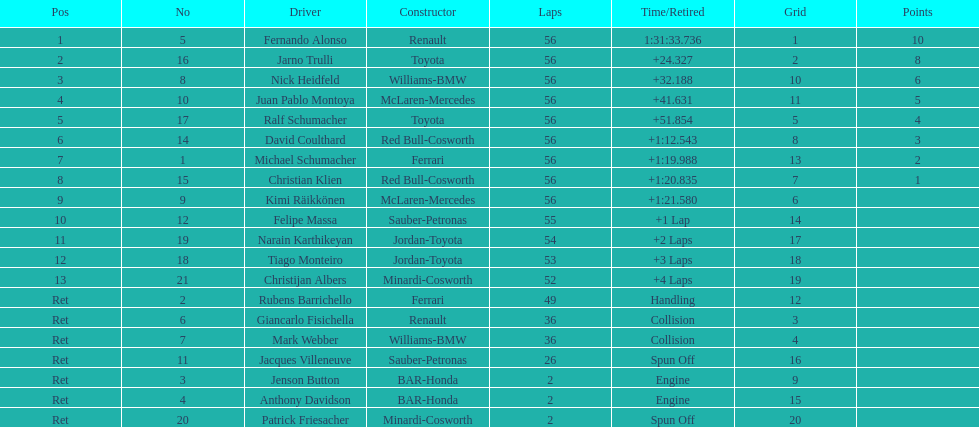In what amount of time did heidfeld complete? 1:31:65.924. Can you give me this table as a dict? {'header': ['Pos', 'No', 'Driver', 'Constructor', 'Laps', 'Time/Retired', 'Grid', 'Points'], 'rows': [['1', '5', 'Fernando Alonso', 'Renault', '56', '1:31:33.736', '1', '10'], ['2', '16', 'Jarno Trulli', 'Toyota', '56', '+24.327', '2', '8'], ['3', '8', 'Nick Heidfeld', 'Williams-BMW', '56', '+32.188', '10', '6'], ['4', '10', 'Juan Pablo Montoya', 'McLaren-Mercedes', '56', '+41.631', '11', '5'], ['5', '17', 'Ralf Schumacher', 'Toyota', '56', '+51.854', '5', '4'], ['6', '14', 'David Coulthard', 'Red Bull-Cosworth', '56', '+1:12.543', '8', '3'], ['7', '1', 'Michael Schumacher', 'Ferrari', '56', '+1:19.988', '13', '2'], ['8', '15', 'Christian Klien', 'Red Bull-Cosworth', '56', '+1:20.835', '7', '1'], ['9', '9', 'Kimi Räikkönen', 'McLaren-Mercedes', '56', '+1:21.580', '6', ''], ['10', '12', 'Felipe Massa', 'Sauber-Petronas', '55', '+1 Lap', '14', ''], ['11', '19', 'Narain Karthikeyan', 'Jordan-Toyota', '54', '+2 Laps', '17', ''], ['12', '18', 'Tiago Monteiro', 'Jordan-Toyota', '53', '+3 Laps', '18', ''], ['13', '21', 'Christijan Albers', 'Minardi-Cosworth', '52', '+4 Laps', '19', ''], ['Ret', '2', 'Rubens Barrichello', 'Ferrari', '49', 'Handling', '12', ''], ['Ret', '6', 'Giancarlo Fisichella', 'Renault', '36', 'Collision', '3', ''], ['Ret', '7', 'Mark Webber', 'Williams-BMW', '36', 'Collision', '4', ''], ['Ret', '11', 'Jacques Villeneuve', 'Sauber-Petronas', '26', 'Spun Off', '16', ''], ['Ret', '3', 'Jenson Button', 'BAR-Honda', '2', 'Engine', '9', ''], ['Ret', '4', 'Anthony Davidson', 'BAR-Honda', '2', 'Engine', '15', ''], ['Ret', '20', 'Patrick Friesacher', 'Minardi-Cosworth', '2', 'Spun Off', '20', '']]} 